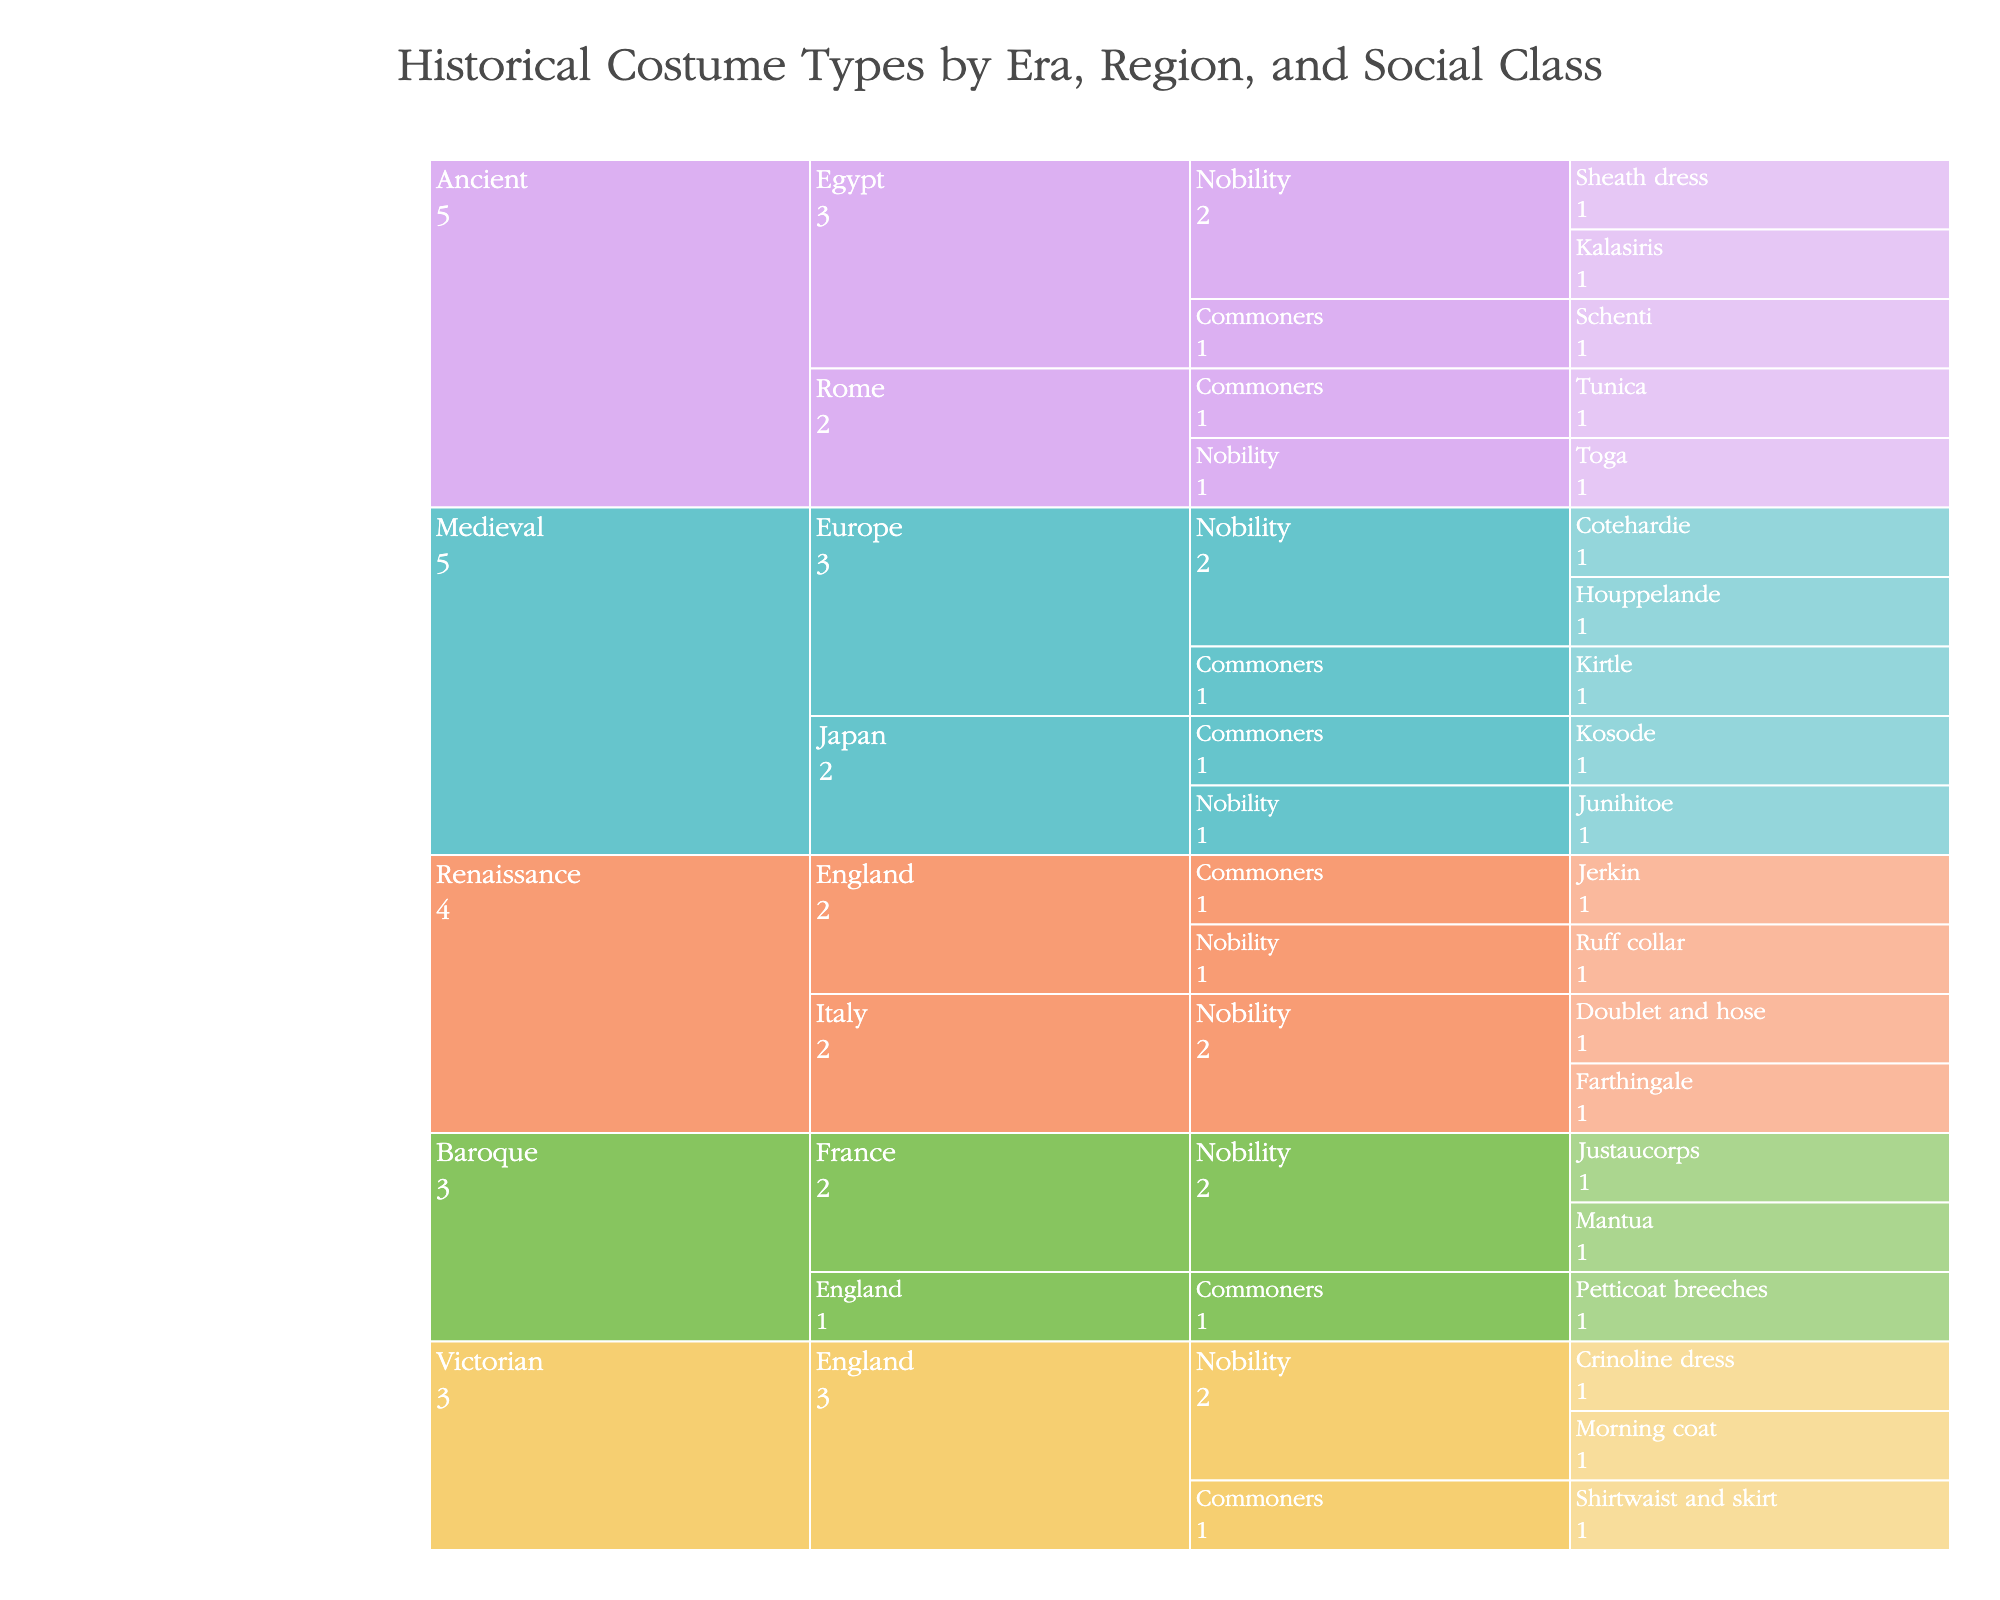what era has the most costume types represented? To find the era with the most costume types, we need to count the number of costume types listed under each era. By inspecting the figure, the "Ancient" era has the most costume types.
Answer: Ancient How many regions are represented in the "Medieval" era? Look at the branches under the "Medieval" era. There are two regions represented: Europe and Japan.
Answer: 2 Which social class in "Renaissance Italy" has the most costume types? By inspecting the branches under "Renaissance Italy", the "Nobility" class has all the listed costume types, meaning it has the most.
Answer: Nobility Compare the number of "Nobility" versus "Commoners" costume types in the "Victorian" era. Under the "Victorian" era, count the costume types under "Nobility" (Crinoline dress, Morning coat) and "Commoners" (Shirtwaist and skirt). The counts are 2 and 1, respectively.
Answer: Nobility has more What is the unique costume type listed under "Ancient Rome" for commoners? Look for the branch under "Ancient Rome" and "Commoners." The unique costume type listed is "Tunica."
Answer: Tunica How many costume types are there in "Baroque France"? Under "Baroque France," count the listed costume types. There are two: Justaucorps and Mantua.
Answer: 2 Which era and region have "Kirtle" listed as a costume type? Navigate the branches to find "Kirtle." It is listed under "Medieval Europe."
Answer: Medieval Europe If we combine the counts of "Commoners" costume types from "Renaissance," "Medieval," and "Ancient" eras, how many are there in total? Add the number of "Commoners" costume types from each era: Renaissance (1 - Jerkin), Medieval (1 - Kirtle, 1 - Kosode), Ancient (1 - Schenti). Total is 1 + 2 + 1 = 4.
Answer: 4 Which region has the most varied costume types in the "Nobility" social class? Count the costume types listed under "Nobility" for each region and compare. Europe in the "Medieval" era has the most varied costume types with 2.
Answer: Europe (Medieval) What is the main difference in the number of costume types represented between "Nobility" and "Commoners" in "Medieval Japan"? Count the costume types under "Medieval Japan" for "Nobility" (Junihitoe) and "Commoners" (Kosode). Both have 1 costume type, so there is no difference.
Answer: No difference 